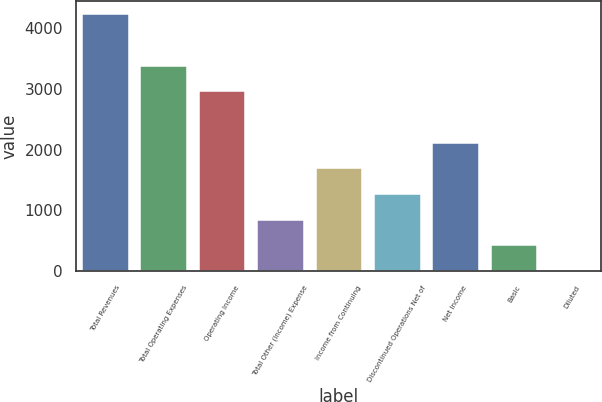<chart> <loc_0><loc_0><loc_500><loc_500><bar_chart><fcel>Total Revenues<fcel>Total Operating Expenses<fcel>Operating Income<fcel>Total Other (Income) Expense<fcel>Income from Continuing<fcel>Discontinued Operations Net of<fcel>Net Income<fcel>Basic<fcel>Diluted<nl><fcel>4223<fcel>3379.45<fcel>2957.69<fcel>848.89<fcel>1692.41<fcel>1270.65<fcel>2114.17<fcel>427.13<fcel>5.37<nl></chart> 